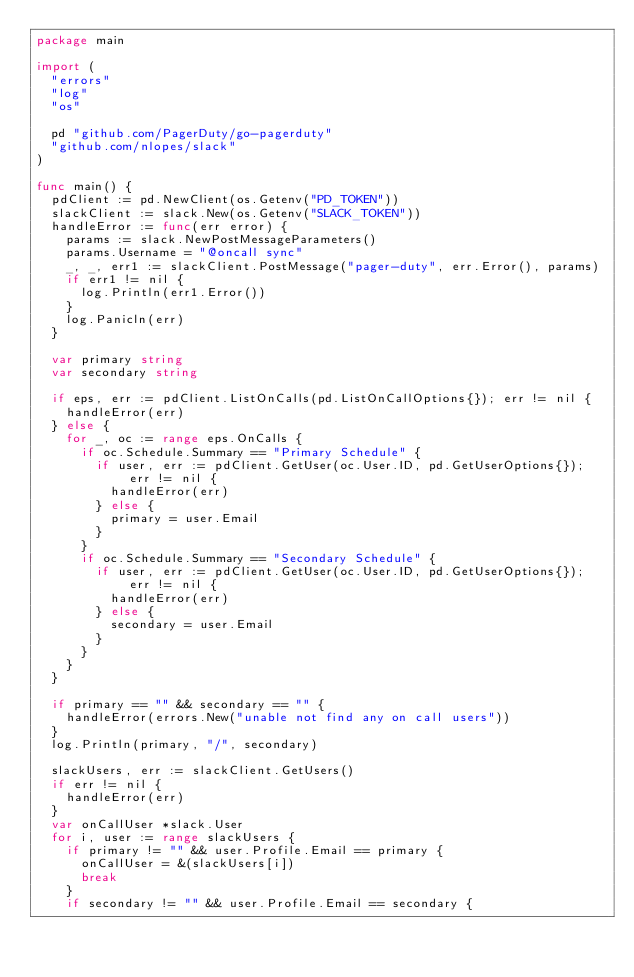<code> <loc_0><loc_0><loc_500><loc_500><_Go_>package main

import (
	"errors"
	"log"
	"os"

	pd "github.com/PagerDuty/go-pagerduty"
	"github.com/nlopes/slack"
)

func main() {
	pdClient := pd.NewClient(os.Getenv("PD_TOKEN"))
	slackClient := slack.New(os.Getenv("SLACK_TOKEN"))
	handleError := func(err error) {
		params := slack.NewPostMessageParameters()
		params.Username = "@oncall sync"
		_, _, err1 := slackClient.PostMessage("pager-duty", err.Error(), params)
		if err1 != nil {
			log.Println(err1.Error())
		}
		log.Panicln(err)
	}

	var primary string
	var secondary string

	if eps, err := pdClient.ListOnCalls(pd.ListOnCallOptions{}); err != nil {
		handleError(err)
	} else {
		for _, oc := range eps.OnCalls {
			if oc.Schedule.Summary == "Primary Schedule" {
				if user, err := pdClient.GetUser(oc.User.ID, pd.GetUserOptions{}); err != nil {
					handleError(err)
				} else {
					primary = user.Email
				}
			}
			if oc.Schedule.Summary == "Secondary Schedule" {
				if user, err := pdClient.GetUser(oc.User.ID, pd.GetUserOptions{}); err != nil {
					handleError(err)
				} else {
					secondary = user.Email
				}
			}
		}
	}

	if primary == "" && secondary == "" {
		handleError(errors.New("unable not find any on call users"))
	}
	log.Println(primary, "/", secondary)

	slackUsers, err := slackClient.GetUsers()
	if err != nil {
		handleError(err)
	}
	var onCallUser *slack.User
	for i, user := range slackUsers {
		if primary != "" && user.Profile.Email == primary {
			onCallUser = &(slackUsers[i])
			break
		}
		if secondary != "" && user.Profile.Email == secondary {</code> 